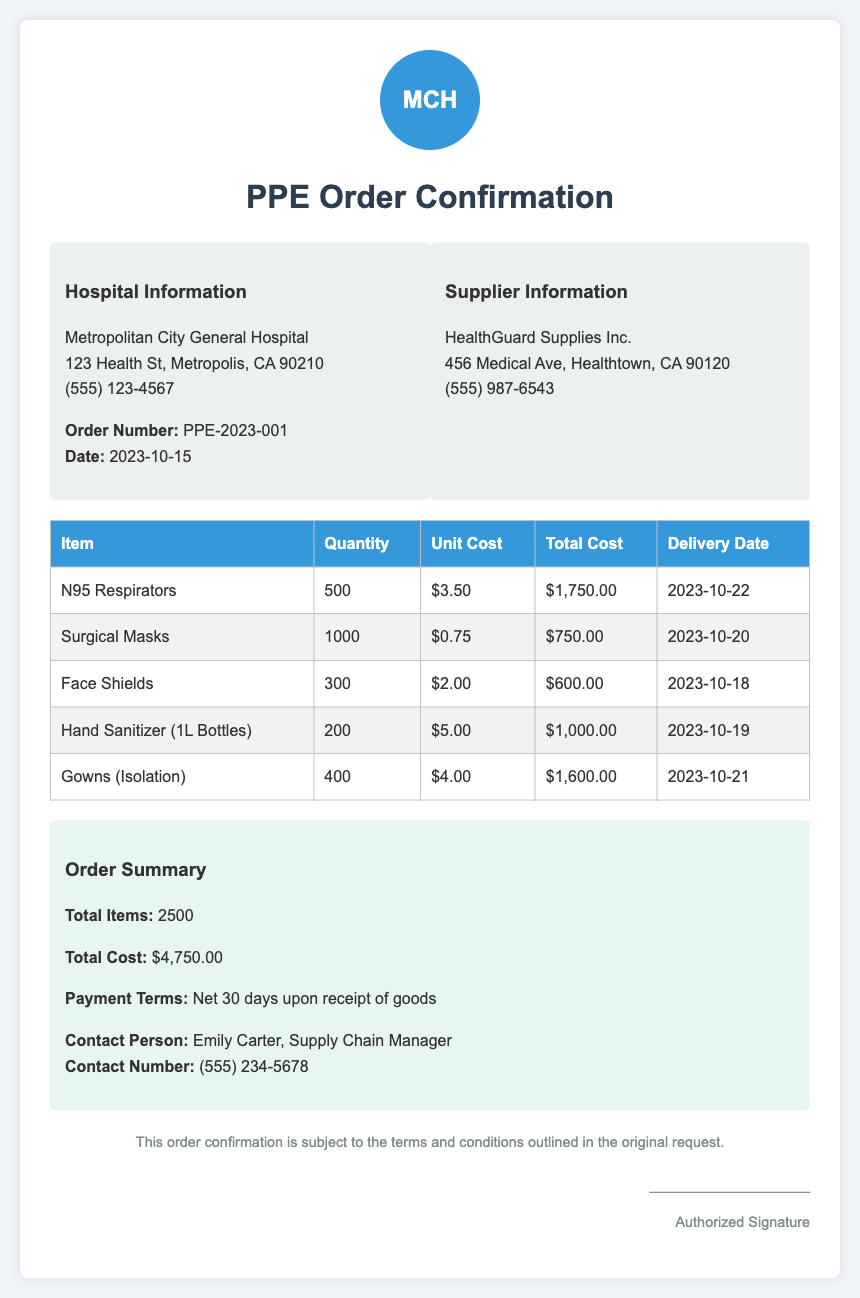What is the order number? The order number is listed in the hospital information section of the document.
Answer: PPE-2023-001 What is the total cost of the order? The total cost is provided in the order summary section of the document.
Answer: $4,750.00 How many N95 respirators were ordered? The number of N95 respirators is specified in the table of items ordered.
Answer: 500 What is the delivery date for the surgical masks? The delivery date for surgical masks can be found in the delivery date column of the items table.
Answer: 2023-10-20 Who is the contact person for this order? The contact person is mentioned in the order summary section of the document.
Answer: Emily Carter What are the payment terms? The payment terms are detailed in the order summary section.
Answer: Net 30 days upon receipt of goods How many total items were ordered? The total number of items ordered is calculated from the information in the summary section.
Answer: 2500 Which supplier is providing the PPE supplies? The supplier's information is included in the supplier information section of the document.
Answer: HealthGuard Supplies Inc What is the unit cost of hand sanitizer? The unit cost of hand sanitizer is found in the items table under unit cost.
Answer: $5.00 